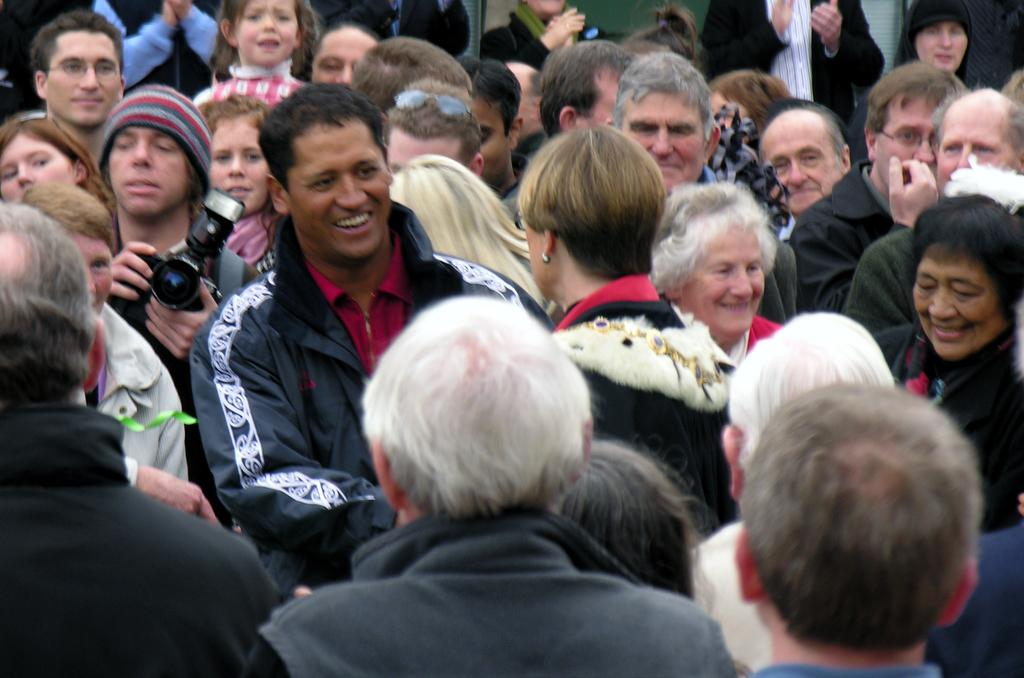What can be observed about the people in the image? There are people standing in the image. What is the man holding in the image? A man is holding a camera in the image. What letters are being used to communicate with the people in the image? There are no letters present in the image; it only shows people standing and a man holding a camera. 